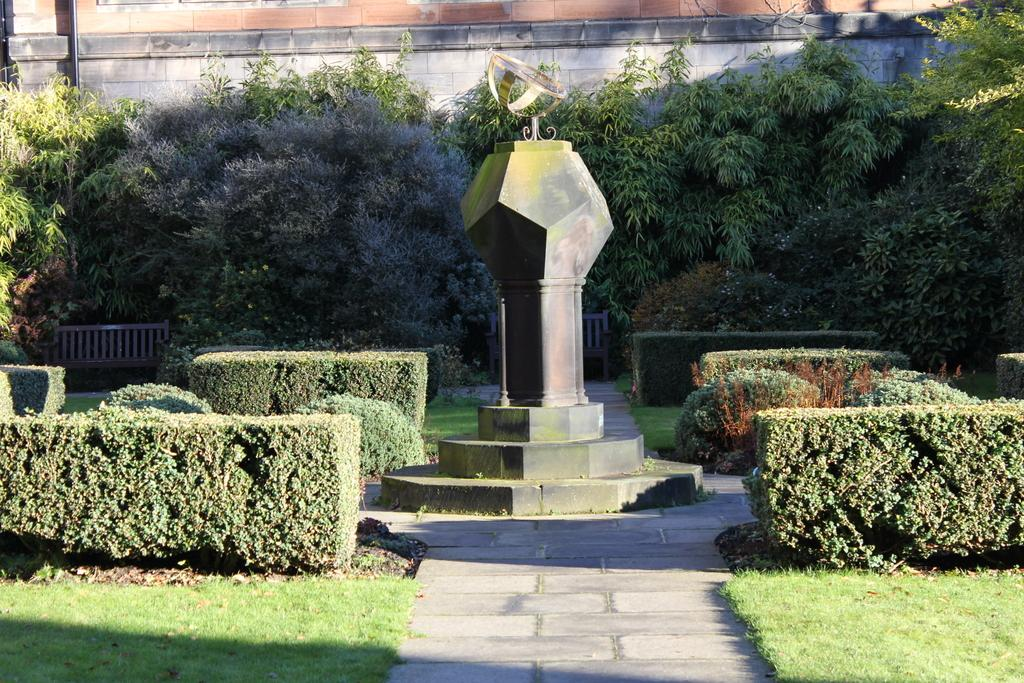What type of vegetation can be seen in the image? There are plants and trees in the image. What structure is present in the image? There is a pole in the image. What might the image depict based on the presence of plants, trees, and a pole? The image appears to depict a park. What type of worm can be seen crawling on the pole in the image? There are no worms present in the image, and therefore no such activity can be observed. 